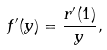Convert formula to latex. <formula><loc_0><loc_0><loc_500><loc_500>f ^ { \prime } ( y ) = \frac { r ^ { \prime } ( 1 ) } { y } ,</formula> 